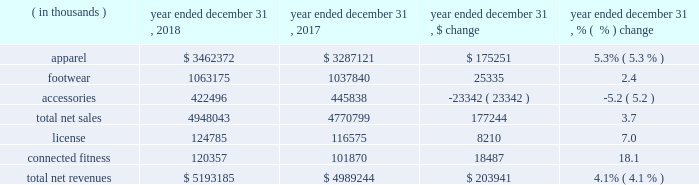Consolidated results of operations year ended december 31 , 2018 compared to year ended december 31 , 2017 net revenues increased $ 203.9 million , or 4.1% ( 4.1 % ) , to $ 5193.2 million in 2018 from $ 4989.2 million in 2017 .
Net revenues by product category are summarized below: .
The increase in net sales was driven primarily by : 2022 apparel unit sales growth driven by the train category ; and 2022 footwear unit sales growth , led by the run category .
The increase was partially offset by unit sales decline in accessories .
License revenues increased $ 8.2 million , or 7.0% ( 7.0 % ) , to $ 124.8 million in 2018 from $ 116.6 million in 2017 .
Connected fitness revenue increased $ 18.5 million , or 18.1% ( 18.1 % ) , to $ 120.4 million in 2018 from $ 101.9 million in 2017 primarily driven by increased subscribers on our fitness applications .
Gross profit increased $ 89.1 million to $ 2340.5 million in 2018 from $ 2251.4 million in 2017 .
Gross profit as a percentage of net revenues , or gross margin , was unchanged at 45.1% ( 45.1 % ) in 2018 compared to 2017 .
Gross profit percentage was favorably impacted by lower promotional activity , improvements in product cost , lower air freight , higher proportion of international and connected fitness revenue and changes in foreign currency ; these favorable impacts were offset by channel mix including higher sales to our off-price channel and restructuring related charges .
With the exception of improvements in product input costs and air freight improvements , we do not expect these trends to have a material impact on the full year 2019 .
Selling , general and administrative expenses increased $ 82.8 million to $ 2182.3 million in 2018 from $ 2099.5 million in 2017 .
As a percentage of net revenues , selling , general and administrative expenses decreased slightly to 42.0% ( 42.0 % ) in 2018 from 42.1% ( 42.1 % ) in 2017 .
Selling , general and administrative expense was impacted by the following : 2022 marketing costs decreased $ 21.3 million to $ 543.8 million in 2018 from $ 565.1 million in 2017 .
This decrease was primarily due to restructuring efforts , resulting in lower compensation and contractual sports marketing .
This decrease was partially offset by higher costs in connection with brand marketing campaigns and increased marketing investments with the growth of our international business .
As a percentage of net revenues , marketing costs decreased to 10.5% ( 10.5 % ) in 2018 from 11.3% ( 11.3 % ) in 2017 .
2022 other costs increased $ 104.1 million to $ 1638.5 million in 2018 from $ 1534.4 million in 2017 .
This increase was primarily due to higher incentive compensation expense and higher costs incurred for the continued expansion of our direct to consumer distribution channel and international business .
As a percentage of net revenues , other costs increased to 31.6% ( 31.6 % ) in 2018 from 30.8% ( 30.8 % ) in 2017 .
Restructuring and impairment charges increased $ 59.1 million to $ 183.1 million from $ 124.0 million in 2017 .
Refer to the restructuring plans section above for a summary of charges .
Income ( loss ) from operations decreased $ 52.8 million , or 189.9% ( 189.9 % ) , to a loss of $ 25.0 million in 2018 from income of $ 27.8 million in 2017 .
As a percentage of net revenues , income from operations decreased to a loss of 0.4% ( 0.4 % ) in 2018 from income of 0.5% ( 0.5 % ) in 2017 .
Income from operations for the year ended december 31 , 2018 was negatively impacted by $ 203.9 million of restructuring , impairment and related charges in connection with the 2018 restructuring plan .
Income from operations for the year ended december 31 , 2017 was negatively impacted by $ 129.1 million of restructuring , impairment and related charges in connection with the 2017 restructuring plan .
Interest expense , net decreased $ 0.9 million to $ 33.6 million in 2018 from $ 34.5 million in 2017. .
What is the gross margin in 2018? 
Computations: (2340.5 / (5193185 / 1000))
Answer: 0.45069. 